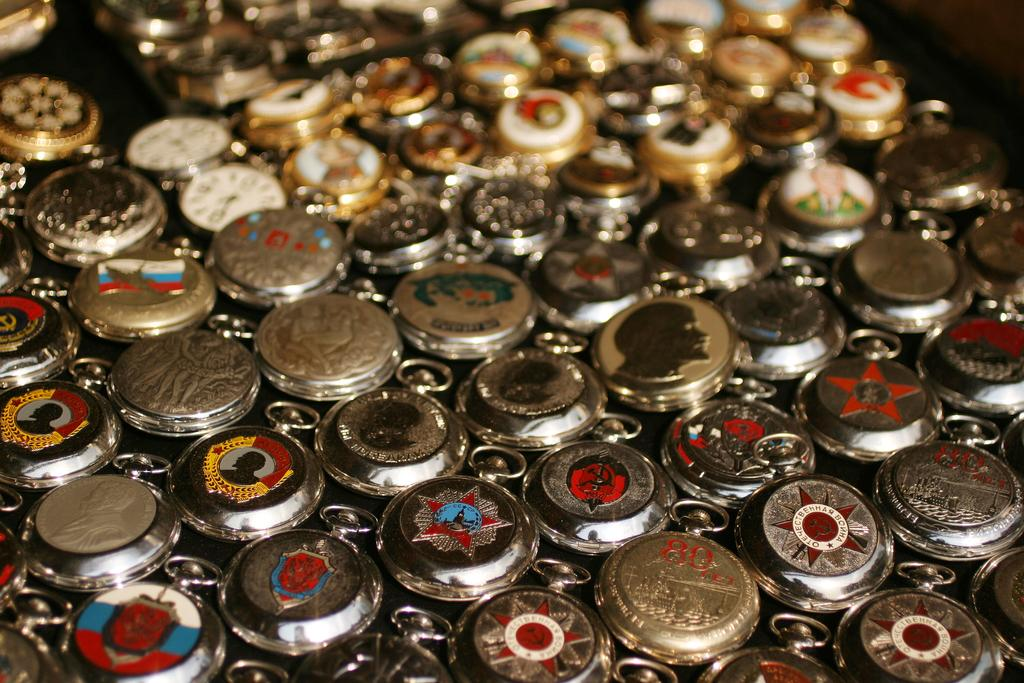What objects are in the middle of the image? There are different types of coins in the image. Can you describe the coins in the image? The coins are of different types. What type of eggs are being knitted on the stage in the image? There are no eggs, knitting, or stage present in the image; it features different types of coins. 